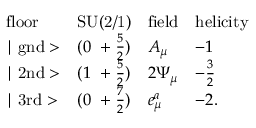<formula> <loc_0><loc_0><loc_500><loc_500>\begin{array} { l c l l } { f l o o r } & { S U ( 2 / 1 ) } & { f i e l d } & { h e l i c i t y } \\ { | g n d > } & { { ( 0 + \frac { 5 } { 2 } ) } } & { { A _ { \mu } } } & { - 1 } \\ { | 2 n d > } & { { ( 1 + \frac { 5 } { 2 } ) } } & { { 2 \Psi _ { \mu } } } & { { - \frac { 3 } { 2 } } } \\ { | 3 r d > } & { { ( 0 + \frac { 7 } { 2 } ) } } & { { e _ { \mu } ^ { a } } } & { - 2 . } \end{array}</formula> 